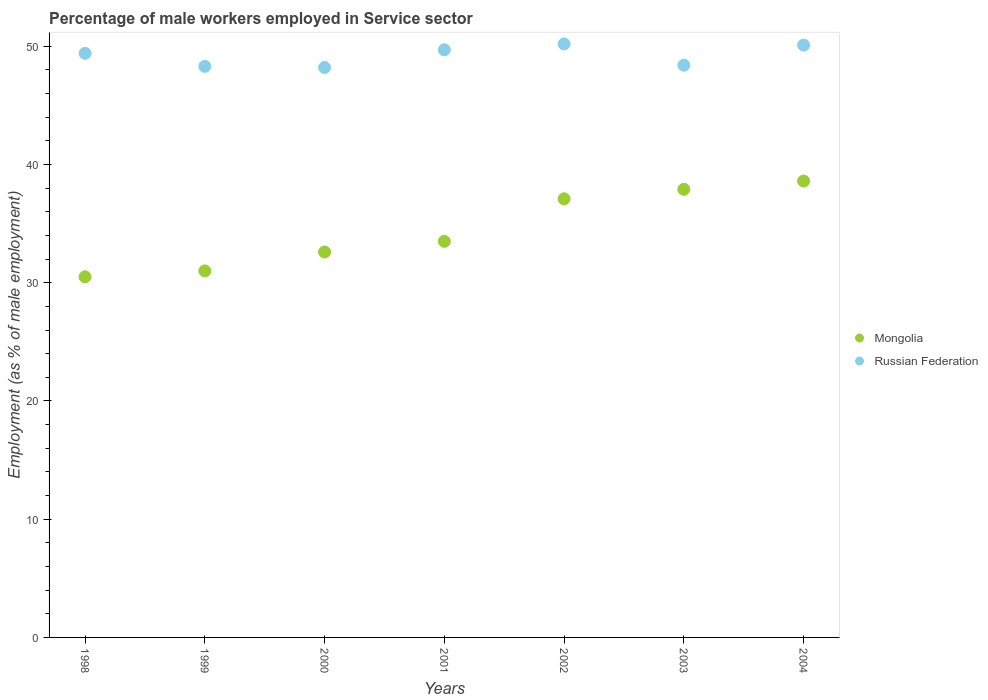What is the percentage of male workers employed in Service sector in Mongolia in 2001?
Make the answer very short. 33.5. Across all years, what is the maximum percentage of male workers employed in Service sector in Mongolia?
Make the answer very short. 38.6. Across all years, what is the minimum percentage of male workers employed in Service sector in Mongolia?
Your answer should be very brief. 30.5. In which year was the percentage of male workers employed in Service sector in Russian Federation maximum?
Provide a short and direct response. 2002. In which year was the percentage of male workers employed in Service sector in Russian Federation minimum?
Provide a succinct answer. 2000. What is the total percentage of male workers employed in Service sector in Mongolia in the graph?
Give a very brief answer. 241.2. What is the difference between the percentage of male workers employed in Service sector in Russian Federation in 1999 and that in 2001?
Provide a short and direct response. -1.4. What is the difference between the percentage of male workers employed in Service sector in Mongolia in 2004 and the percentage of male workers employed in Service sector in Russian Federation in 2001?
Ensure brevity in your answer.  -11.1. What is the average percentage of male workers employed in Service sector in Russian Federation per year?
Your answer should be compact. 49.19. In the year 1998, what is the difference between the percentage of male workers employed in Service sector in Mongolia and percentage of male workers employed in Service sector in Russian Federation?
Provide a succinct answer. -18.9. What is the ratio of the percentage of male workers employed in Service sector in Mongolia in 1999 to that in 2003?
Offer a very short reply. 0.82. Is the difference between the percentage of male workers employed in Service sector in Mongolia in 1998 and 2001 greater than the difference between the percentage of male workers employed in Service sector in Russian Federation in 1998 and 2001?
Provide a succinct answer. No. What is the difference between the highest and the second highest percentage of male workers employed in Service sector in Russian Federation?
Your answer should be very brief. 0.1. What is the difference between the highest and the lowest percentage of male workers employed in Service sector in Russian Federation?
Offer a very short reply. 2. Is the percentage of male workers employed in Service sector in Russian Federation strictly greater than the percentage of male workers employed in Service sector in Mongolia over the years?
Ensure brevity in your answer.  Yes. Is the percentage of male workers employed in Service sector in Mongolia strictly less than the percentage of male workers employed in Service sector in Russian Federation over the years?
Keep it short and to the point. Yes. How many dotlines are there?
Give a very brief answer. 2. How many years are there in the graph?
Your answer should be very brief. 7. Does the graph contain any zero values?
Ensure brevity in your answer.  No. Does the graph contain grids?
Your answer should be very brief. No. Where does the legend appear in the graph?
Make the answer very short. Center right. How many legend labels are there?
Offer a terse response. 2. What is the title of the graph?
Provide a short and direct response. Percentage of male workers employed in Service sector. Does "St. Kitts and Nevis" appear as one of the legend labels in the graph?
Offer a very short reply. No. What is the label or title of the Y-axis?
Offer a very short reply. Employment (as % of male employment). What is the Employment (as % of male employment) of Mongolia in 1998?
Keep it short and to the point. 30.5. What is the Employment (as % of male employment) of Russian Federation in 1998?
Offer a terse response. 49.4. What is the Employment (as % of male employment) in Mongolia in 1999?
Make the answer very short. 31. What is the Employment (as % of male employment) in Russian Federation in 1999?
Give a very brief answer. 48.3. What is the Employment (as % of male employment) of Mongolia in 2000?
Your response must be concise. 32.6. What is the Employment (as % of male employment) in Russian Federation in 2000?
Offer a very short reply. 48.2. What is the Employment (as % of male employment) in Mongolia in 2001?
Provide a short and direct response. 33.5. What is the Employment (as % of male employment) of Russian Federation in 2001?
Your response must be concise. 49.7. What is the Employment (as % of male employment) in Mongolia in 2002?
Your answer should be compact. 37.1. What is the Employment (as % of male employment) of Russian Federation in 2002?
Give a very brief answer. 50.2. What is the Employment (as % of male employment) of Mongolia in 2003?
Give a very brief answer. 37.9. What is the Employment (as % of male employment) in Russian Federation in 2003?
Your answer should be compact. 48.4. What is the Employment (as % of male employment) in Mongolia in 2004?
Ensure brevity in your answer.  38.6. What is the Employment (as % of male employment) of Russian Federation in 2004?
Provide a succinct answer. 50.1. Across all years, what is the maximum Employment (as % of male employment) of Mongolia?
Provide a short and direct response. 38.6. Across all years, what is the maximum Employment (as % of male employment) of Russian Federation?
Offer a terse response. 50.2. Across all years, what is the minimum Employment (as % of male employment) of Mongolia?
Make the answer very short. 30.5. Across all years, what is the minimum Employment (as % of male employment) in Russian Federation?
Provide a short and direct response. 48.2. What is the total Employment (as % of male employment) of Mongolia in the graph?
Give a very brief answer. 241.2. What is the total Employment (as % of male employment) in Russian Federation in the graph?
Provide a short and direct response. 344.3. What is the difference between the Employment (as % of male employment) in Russian Federation in 1998 and that in 1999?
Ensure brevity in your answer.  1.1. What is the difference between the Employment (as % of male employment) of Mongolia in 1998 and that in 2001?
Offer a terse response. -3. What is the difference between the Employment (as % of male employment) in Russian Federation in 1998 and that in 2001?
Provide a succinct answer. -0.3. What is the difference between the Employment (as % of male employment) in Mongolia in 1998 and that in 2002?
Your answer should be compact. -6.6. What is the difference between the Employment (as % of male employment) in Russian Federation in 1998 and that in 2003?
Offer a very short reply. 1. What is the difference between the Employment (as % of male employment) in Mongolia in 1998 and that in 2004?
Your response must be concise. -8.1. What is the difference between the Employment (as % of male employment) of Mongolia in 1999 and that in 2001?
Provide a succinct answer. -2.5. What is the difference between the Employment (as % of male employment) of Russian Federation in 1999 and that in 2002?
Provide a succinct answer. -1.9. What is the difference between the Employment (as % of male employment) of Russian Federation in 1999 and that in 2003?
Your response must be concise. -0.1. What is the difference between the Employment (as % of male employment) in Mongolia in 1999 and that in 2004?
Keep it short and to the point. -7.6. What is the difference between the Employment (as % of male employment) of Russian Federation in 1999 and that in 2004?
Your response must be concise. -1.8. What is the difference between the Employment (as % of male employment) in Russian Federation in 2000 and that in 2002?
Ensure brevity in your answer.  -2. What is the difference between the Employment (as % of male employment) of Mongolia in 2000 and that in 2003?
Your answer should be very brief. -5.3. What is the difference between the Employment (as % of male employment) in Russian Federation in 2000 and that in 2003?
Provide a short and direct response. -0.2. What is the difference between the Employment (as % of male employment) of Mongolia in 2001 and that in 2002?
Provide a succinct answer. -3.6. What is the difference between the Employment (as % of male employment) in Russian Federation in 2001 and that in 2002?
Your answer should be very brief. -0.5. What is the difference between the Employment (as % of male employment) of Mongolia in 2001 and that in 2003?
Give a very brief answer. -4.4. What is the difference between the Employment (as % of male employment) in Mongolia in 2003 and that in 2004?
Make the answer very short. -0.7. What is the difference between the Employment (as % of male employment) of Russian Federation in 2003 and that in 2004?
Provide a succinct answer. -1.7. What is the difference between the Employment (as % of male employment) in Mongolia in 1998 and the Employment (as % of male employment) in Russian Federation in 1999?
Keep it short and to the point. -17.8. What is the difference between the Employment (as % of male employment) of Mongolia in 1998 and the Employment (as % of male employment) of Russian Federation in 2000?
Your answer should be very brief. -17.7. What is the difference between the Employment (as % of male employment) of Mongolia in 1998 and the Employment (as % of male employment) of Russian Federation in 2001?
Offer a terse response. -19.2. What is the difference between the Employment (as % of male employment) of Mongolia in 1998 and the Employment (as % of male employment) of Russian Federation in 2002?
Offer a very short reply. -19.7. What is the difference between the Employment (as % of male employment) in Mongolia in 1998 and the Employment (as % of male employment) in Russian Federation in 2003?
Offer a very short reply. -17.9. What is the difference between the Employment (as % of male employment) in Mongolia in 1998 and the Employment (as % of male employment) in Russian Federation in 2004?
Give a very brief answer. -19.6. What is the difference between the Employment (as % of male employment) of Mongolia in 1999 and the Employment (as % of male employment) of Russian Federation in 2000?
Provide a succinct answer. -17.2. What is the difference between the Employment (as % of male employment) of Mongolia in 1999 and the Employment (as % of male employment) of Russian Federation in 2001?
Give a very brief answer. -18.7. What is the difference between the Employment (as % of male employment) of Mongolia in 1999 and the Employment (as % of male employment) of Russian Federation in 2002?
Keep it short and to the point. -19.2. What is the difference between the Employment (as % of male employment) of Mongolia in 1999 and the Employment (as % of male employment) of Russian Federation in 2003?
Offer a terse response. -17.4. What is the difference between the Employment (as % of male employment) in Mongolia in 1999 and the Employment (as % of male employment) in Russian Federation in 2004?
Your answer should be compact. -19.1. What is the difference between the Employment (as % of male employment) of Mongolia in 2000 and the Employment (as % of male employment) of Russian Federation in 2001?
Your response must be concise. -17.1. What is the difference between the Employment (as % of male employment) of Mongolia in 2000 and the Employment (as % of male employment) of Russian Federation in 2002?
Provide a short and direct response. -17.6. What is the difference between the Employment (as % of male employment) of Mongolia in 2000 and the Employment (as % of male employment) of Russian Federation in 2003?
Your answer should be compact. -15.8. What is the difference between the Employment (as % of male employment) of Mongolia in 2000 and the Employment (as % of male employment) of Russian Federation in 2004?
Your answer should be very brief. -17.5. What is the difference between the Employment (as % of male employment) in Mongolia in 2001 and the Employment (as % of male employment) in Russian Federation in 2002?
Give a very brief answer. -16.7. What is the difference between the Employment (as % of male employment) in Mongolia in 2001 and the Employment (as % of male employment) in Russian Federation in 2003?
Give a very brief answer. -14.9. What is the difference between the Employment (as % of male employment) in Mongolia in 2001 and the Employment (as % of male employment) in Russian Federation in 2004?
Provide a short and direct response. -16.6. What is the difference between the Employment (as % of male employment) in Mongolia in 2002 and the Employment (as % of male employment) in Russian Federation in 2003?
Keep it short and to the point. -11.3. What is the average Employment (as % of male employment) of Mongolia per year?
Provide a succinct answer. 34.46. What is the average Employment (as % of male employment) of Russian Federation per year?
Make the answer very short. 49.19. In the year 1998, what is the difference between the Employment (as % of male employment) of Mongolia and Employment (as % of male employment) of Russian Federation?
Make the answer very short. -18.9. In the year 1999, what is the difference between the Employment (as % of male employment) of Mongolia and Employment (as % of male employment) of Russian Federation?
Offer a terse response. -17.3. In the year 2000, what is the difference between the Employment (as % of male employment) of Mongolia and Employment (as % of male employment) of Russian Federation?
Keep it short and to the point. -15.6. In the year 2001, what is the difference between the Employment (as % of male employment) in Mongolia and Employment (as % of male employment) in Russian Federation?
Provide a short and direct response. -16.2. In the year 2002, what is the difference between the Employment (as % of male employment) of Mongolia and Employment (as % of male employment) of Russian Federation?
Provide a succinct answer. -13.1. What is the ratio of the Employment (as % of male employment) in Mongolia in 1998 to that in 1999?
Your answer should be compact. 0.98. What is the ratio of the Employment (as % of male employment) of Russian Federation in 1998 to that in 1999?
Offer a very short reply. 1.02. What is the ratio of the Employment (as % of male employment) of Mongolia in 1998 to that in 2000?
Your answer should be very brief. 0.94. What is the ratio of the Employment (as % of male employment) in Russian Federation in 1998 to that in 2000?
Offer a very short reply. 1.02. What is the ratio of the Employment (as % of male employment) of Mongolia in 1998 to that in 2001?
Your answer should be compact. 0.91. What is the ratio of the Employment (as % of male employment) of Russian Federation in 1998 to that in 2001?
Your answer should be very brief. 0.99. What is the ratio of the Employment (as % of male employment) of Mongolia in 1998 to that in 2002?
Ensure brevity in your answer.  0.82. What is the ratio of the Employment (as % of male employment) of Russian Federation in 1998 to that in 2002?
Provide a succinct answer. 0.98. What is the ratio of the Employment (as % of male employment) of Mongolia in 1998 to that in 2003?
Give a very brief answer. 0.8. What is the ratio of the Employment (as % of male employment) in Russian Federation in 1998 to that in 2003?
Offer a terse response. 1.02. What is the ratio of the Employment (as % of male employment) in Mongolia in 1998 to that in 2004?
Ensure brevity in your answer.  0.79. What is the ratio of the Employment (as % of male employment) of Russian Federation in 1998 to that in 2004?
Provide a succinct answer. 0.99. What is the ratio of the Employment (as % of male employment) in Mongolia in 1999 to that in 2000?
Keep it short and to the point. 0.95. What is the ratio of the Employment (as % of male employment) in Russian Federation in 1999 to that in 2000?
Make the answer very short. 1. What is the ratio of the Employment (as % of male employment) of Mongolia in 1999 to that in 2001?
Make the answer very short. 0.93. What is the ratio of the Employment (as % of male employment) in Russian Federation in 1999 to that in 2001?
Give a very brief answer. 0.97. What is the ratio of the Employment (as % of male employment) of Mongolia in 1999 to that in 2002?
Offer a very short reply. 0.84. What is the ratio of the Employment (as % of male employment) of Russian Federation in 1999 to that in 2002?
Your answer should be compact. 0.96. What is the ratio of the Employment (as % of male employment) in Mongolia in 1999 to that in 2003?
Your answer should be very brief. 0.82. What is the ratio of the Employment (as % of male employment) in Russian Federation in 1999 to that in 2003?
Ensure brevity in your answer.  1. What is the ratio of the Employment (as % of male employment) in Mongolia in 1999 to that in 2004?
Ensure brevity in your answer.  0.8. What is the ratio of the Employment (as % of male employment) in Russian Federation in 1999 to that in 2004?
Offer a terse response. 0.96. What is the ratio of the Employment (as % of male employment) of Mongolia in 2000 to that in 2001?
Offer a very short reply. 0.97. What is the ratio of the Employment (as % of male employment) in Russian Federation in 2000 to that in 2001?
Offer a terse response. 0.97. What is the ratio of the Employment (as % of male employment) in Mongolia in 2000 to that in 2002?
Provide a succinct answer. 0.88. What is the ratio of the Employment (as % of male employment) in Russian Federation in 2000 to that in 2002?
Offer a very short reply. 0.96. What is the ratio of the Employment (as % of male employment) in Mongolia in 2000 to that in 2003?
Your answer should be very brief. 0.86. What is the ratio of the Employment (as % of male employment) in Mongolia in 2000 to that in 2004?
Keep it short and to the point. 0.84. What is the ratio of the Employment (as % of male employment) of Russian Federation in 2000 to that in 2004?
Keep it short and to the point. 0.96. What is the ratio of the Employment (as % of male employment) of Mongolia in 2001 to that in 2002?
Keep it short and to the point. 0.9. What is the ratio of the Employment (as % of male employment) in Mongolia in 2001 to that in 2003?
Offer a very short reply. 0.88. What is the ratio of the Employment (as % of male employment) in Russian Federation in 2001 to that in 2003?
Your answer should be compact. 1.03. What is the ratio of the Employment (as % of male employment) of Mongolia in 2001 to that in 2004?
Make the answer very short. 0.87. What is the ratio of the Employment (as % of male employment) in Mongolia in 2002 to that in 2003?
Your answer should be very brief. 0.98. What is the ratio of the Employment (as % of male employment) in Russian Federation in 2002 to that in 2003?
Your response must be concise. 1.04. What is the ratio of the Employment (as % of male employment) of Mongolia in 2002 to that in 2004?
Offer a very short reply. 0.96. What is the ratio of the Employment (as % of male employment) of Mongolia in 2003 to that in 2004?
Give a very brief answer. 0.98. What is the ratio of the Employment (as % of male employment) of Russian Federation in 2003 to that in 2004?
Ensure brevity in your answer.  0.97. What is the difference between the highest and the second highest Employment (as % of male employment) in Russian Federation?
Keep it short and to the point. 0.1. What is the difference between the highest and the lowest Employment (as % of male employment) of Mongolia?
Keep it short and to the point. 8.1. What is the difference between the highest and the lowest Employment (as % of male employment) of Russian Federation?
Your answer should be very brief. 2. 